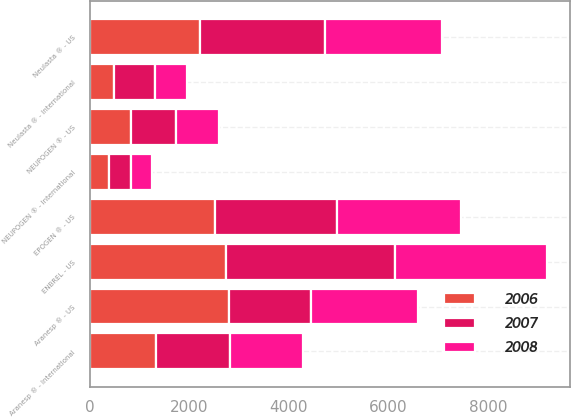Convert chart. <chart><loc_0><loc_0><loc_500><loc_500><stacked_bar_chart><ecel><fcel>Aranesp ® - US<fcel>Aranesp ® - International<fcel>EPOGEN ® - US<fcel>Neulasta ® - US<fcel>NEUPOGEN ® - US<fcel>Neulasta ® - International<fcel>NEUPOGEN ® - International<fcel>ENBREL - US<nl><fcel>2007<fcel>1651<fcel>1486<fcel>2456<fcel>2505<fcel>896<fcel>813<fcel>445<fcel>3389<nl><fcel>2008<fcel>2154<fcel>1460<fcel>2489<fcel>2351<fcel>861<fcel>649<fcel>416<fcel>3052<nl><fcel>2006<fcel>2790<fcel>1331<fcel>2511<fcel>2217<fcel>830<fcel>493<fcel>383<fcel>2736<nl></chart> 